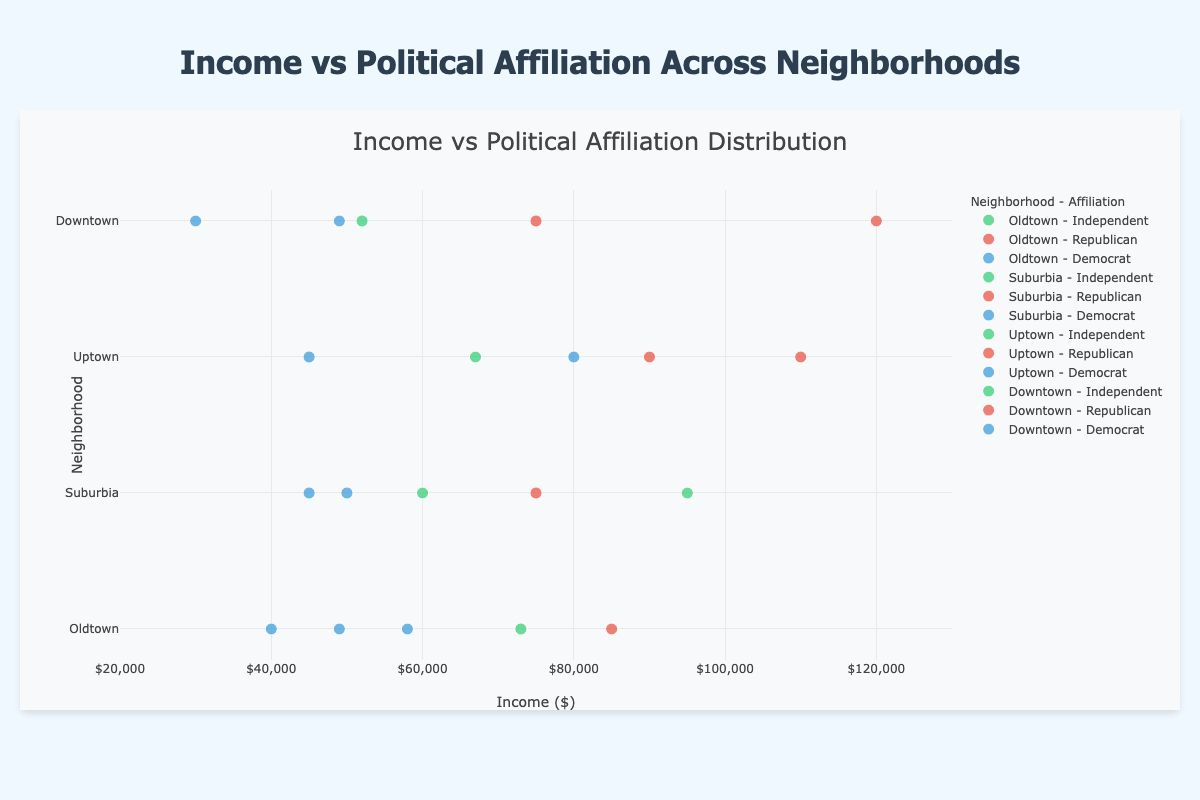What is the title of the plot? The title of the plot is displayed at the top center and reads "Income vs Political Affiliation Distribution".
Answer: Income vs Political Affiliation Distribution What colors are used to represent Democrats, Republicans, and Independents? The Democrats are represented by a blue color, the Republicans by a red color, and the Independents by a green color.
Answer: Blue for Democrats, Red for Republicans, Green for Independents Which neighborhood has the highest income data point and what is that value? From the scatter plot, the highest income value is found in Downtown with an income of $120,000 for a Republican.
Answer: Downtown, $120,000 How many data points are there for each political affiliation in Uptown? In Uptown, there are two Democrats, two Republicans, and one Independent.
Answer: 2 Democrats, 2 Republicans, 1 Independent What is the range of income values in Suburbia? The lowest income in Suburbia is $45,000, and the highest is $95,000. The range is the highest value minus the lowest value: 95,000 - 45,000.
Answer: $50,000 Which neighborhood has the greatest variation in political affiliations and how many different affiliations are there? Downtown, Uptown, and Suburbia all have Democrats, Republicans, and Independents, making them have the greatest variation with three different affiliations each.
Answer: Downtown, Uptown, Suburbia, 3 affiliations each What is the average income of Republicans in Oldtown? There is only one Republican in Oldtown with an income of $85,000. Therefore, the average income for Republicans in Oldtown is $85,000.
Answer: $85,000 Compare the median income of Democrats in Downtown and Uptown. Democrats in Downtown have incomes of $30,000 and $49,000. The median is $49,000. Democrats in Uptown have incomes of $45,000 and $80,000. The median is the average of 45,000 and 80,000, which is $62,500.
Answer: Downtown: $49,000, Uptown: $62,500 Is there any neighborhood where Independents have higher incomes than Republicans? Suburbia has Independents with incomes of $60,000 and $95,000, whereas Republicans have an income of $75,000. Therefore, Independents in Suburbia have higher incomes on average than Republicans.
Answer: Yes, Suburbia 